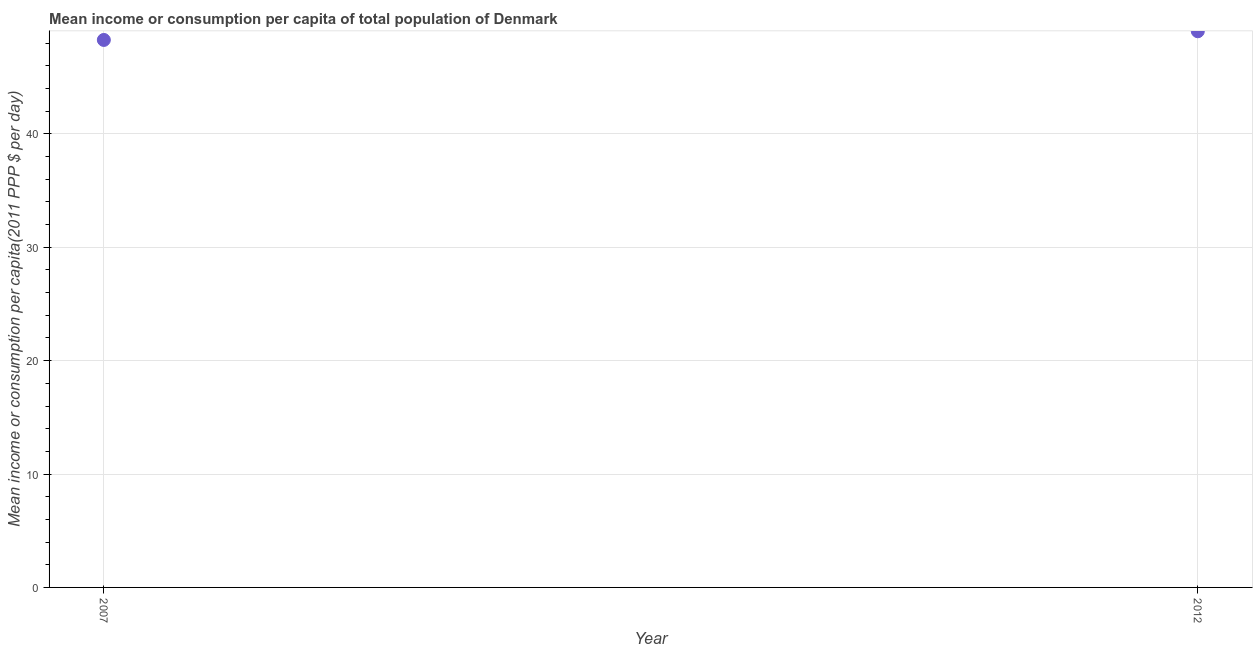What is the mean income or consumption in 2012?
Make the answer very short. 49.05. Across all years, what is the maximum mean income or consumption?
Provide a short and direct response. 49.05. Across all years, what is the minimum mean income or consumption?
Ensure brevity in your answer.  48.29. In which year was the mean income or consumption maximum?
Make the answer very short. 2012. What is the sum of the mean income or consumption?
Provide a succinct answer. 97.34. What is the difference between the mean income or consumption in 2007 and 2012?
Provide a short and direct response. -0.77. What is the average mean income or consumption per year?
Keep it short and to the point. 48.67. What is the median mean income or consumption?
Give a very brief answer. 48.67. What is the ratio of the mean income or consumption in 2007 to that in 2012?
Offer a very short reply. 0.98. Is the mean income or consumption in 2007 less than that in 2012?
Your answer should be very brief. Yes. How many dotlines are there?
Ensure brevity in your answer.  1. Does the graph contain any zero values?
Provide a succinct answer. No. What is the title of the graph?
Offer a very short reply. Mean income or consumption per capita of total population of Denmark. What is the label or title of the X-axis?
Offer a terse response. Year. What is the label or title of the Y-axis?
Your answer should be very brief. Mean income or consumption per capita(2011 PPP $ per day). What is the Mean income or consumption per capita(2011 PPP $ per day) in 2007?
Offer a very short reply. 48.29. What is the Mean income or consumption per capita(2011 PPP $ per day) in 2012?
Give a very brief answer. 49.05. What is the difference between the Mean income or consumption per capita(2011 PPP $ per day) in 2007 and 2012?
Your answer should be very brief. -0.77. 